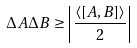Convert formula to latex. <formula><loc_0><loc_0><loc_500><loc_500>\Delta A \Delta B \geq \left | { \frac { \langle [ A , B ] \rangle } { 2 } } \right |</formula> 